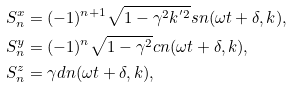Convert formula to latex. <formula><loc_0><loc_0><loc_500><loc_500>S ^ { x } _ { n } & = ( - 1 ) ^ { n + 1 } \sqrt { 1 - \gamma ^ { 2 } k ^ { ^ { \prime } 2 } } s n ( \omega t + \delta , k ) , \\ S ^ { y } _ { n } & = ( - 1 ) ^ { n } \sqrt { 1 - \gamma ^ { 2 } } c n ( \omega t + \delta , k ) , \\ S ^ { z } _ { n } & = \gamma d n ( \omega t + \delta , k ) ,</formula> 